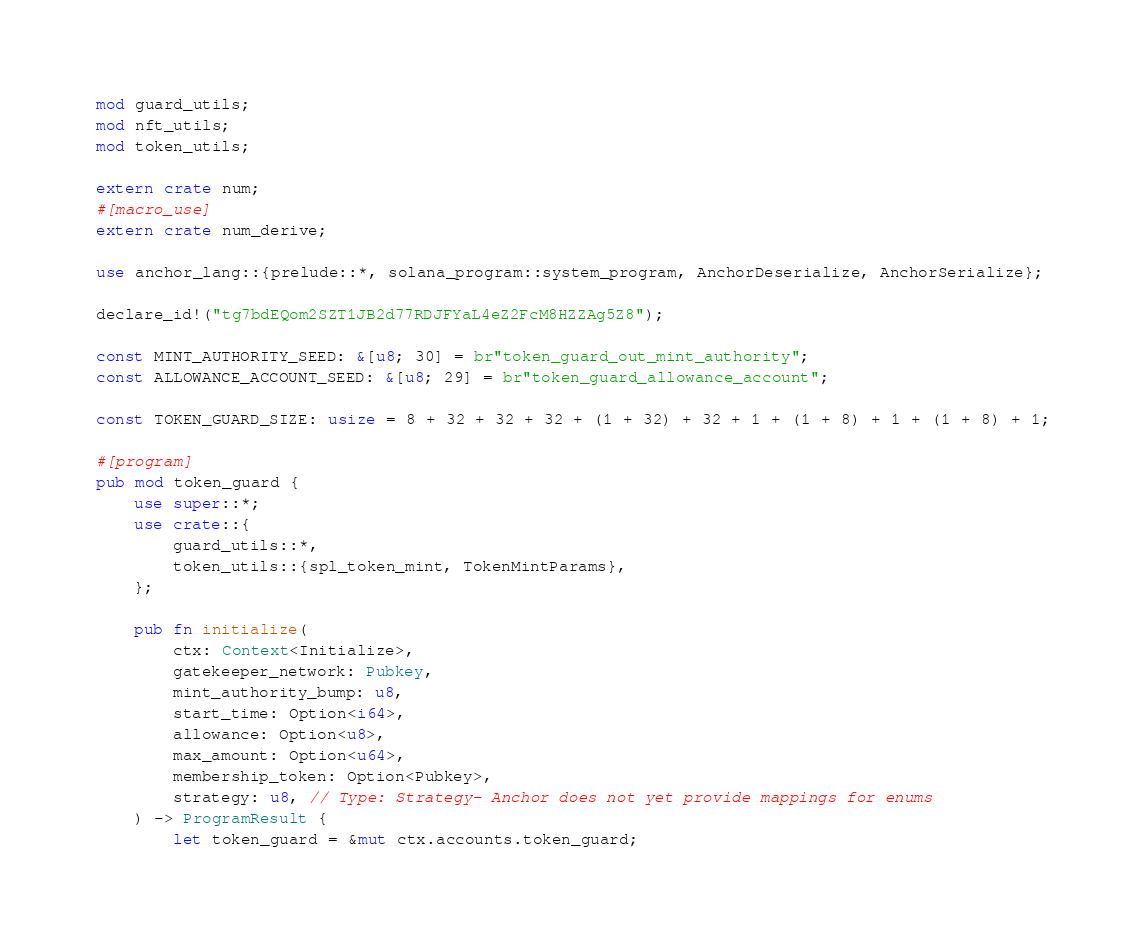Convert code to text. <code><loc_0><loc_0><loc_500><loc_500><_Rust_>mod guard_utils;
mod nft_utils;
mod token_utils;

extern crate num;
#[macro_use]
extern crate num_derive;

use anchor_lang::{prelude::*, solana_program::system_program, AnchorDeserialize, AnchorSerialize};

declare_id!("tg7bdEQom2SZT1JB2d77RDJFYaL4eZ2FcM8HZZAg5Z8");

const MINT_AUTHORITY_SEED: &[u8; 30] = br"token_guard_out_mint_authority";
const ALLOWANCE_ACCOUNT_SEED: &[u8; 29] = br"token_guard_allowance_account";

const TOKEN_GUARD_SIZE: usize = 8 + 32 + 32 + 32 + (1 + 32) + 32 + 1 + (1 + 8) + 1 + (1 + 8) + 1;

#[program]
pub mod token_guard {
    use super::*;
    use crate::{
        guard_utils::*,
        token_utils::{spl_token_mint, TokenMintParams},
    };

    pub fn initialize(
        ctx: Context<Initialize>,
        gatekeeper_network: Pubkey,
        mint_authority_bump: u8,
        start_time: Option<i64>,
        allowance: Option<u8>,
        max_amount: Option<u64>,
        membership_token: Option<Pubkey>,
        strategy: u8, // Type: Strategy- Anchor does not yet provide mappings for enums
    ) -> ProgramResult {
        let token_guard = &mut ctx.accounts.token_guard;</code> 